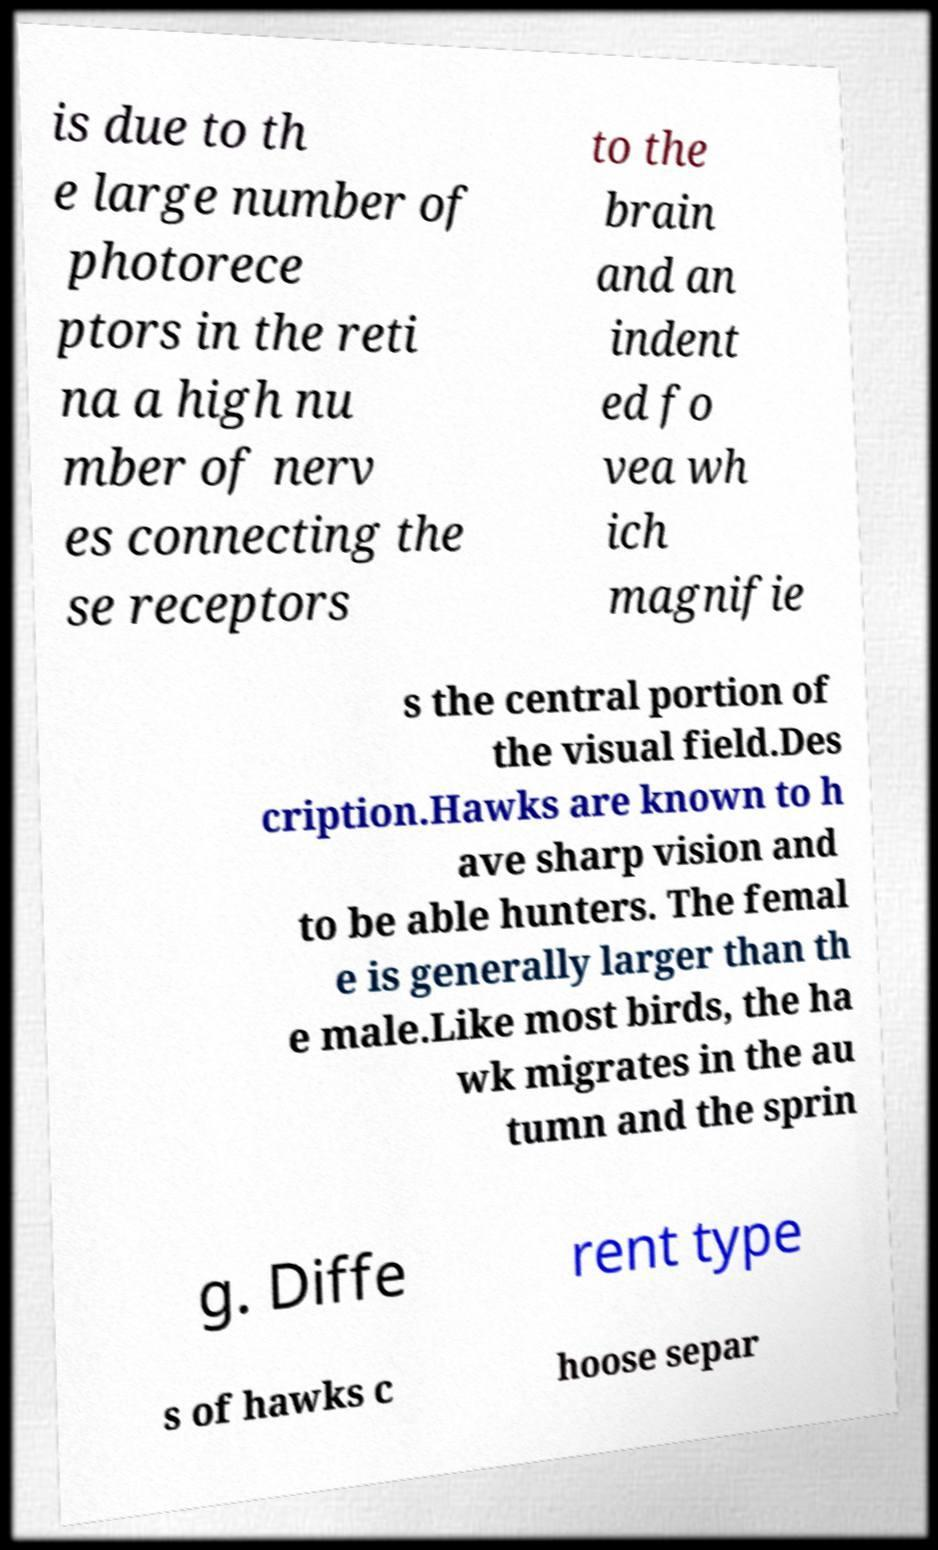Please read and relay the text visible in this image. What does it say? is due to th e large number of photorece ptors in the reti na a high nu mber of nerv es connecting the se receptors to the brain and an indent ed fo vea wh ich magnifie s the central portion of the visual field.Des cription.Hawks are known to h ave sharp vision and to be able hunters. The femal e is generally larger than th e male.Like most birds, the ha wk migrates in the au tumn and the sprin g. Diffe rent type s of hawks c hoose separ 